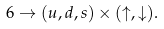<formula> <loc_0><loc_0><loc_500><loc_500>6 \rightarrow ( u , d , s ) \times ( \uparrow , \downarrow ) .</formula> 